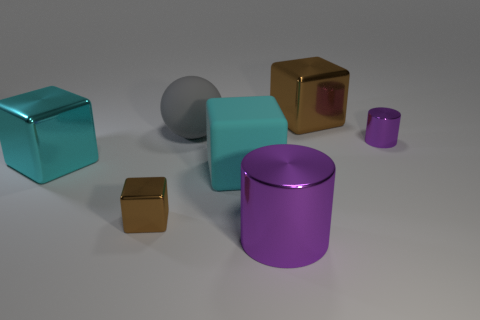Subtract all blue cubes. Subtract all gray balls. How many cubes are left? 4 Add 3 large gray matte balls. How many objects exist? 10 Subtract all spheres. How many objects are left? 6 Add 2 cyan blocks. How many cyan blocks exist? 4 Subtract 0 cyan spheres. How many objects are left? 7 Subtract all purple things. Subtract all red rubber objects. How many objects are left? 5 Add 5 brown shiny blocks. How many brown shiny blocks are left? 7 